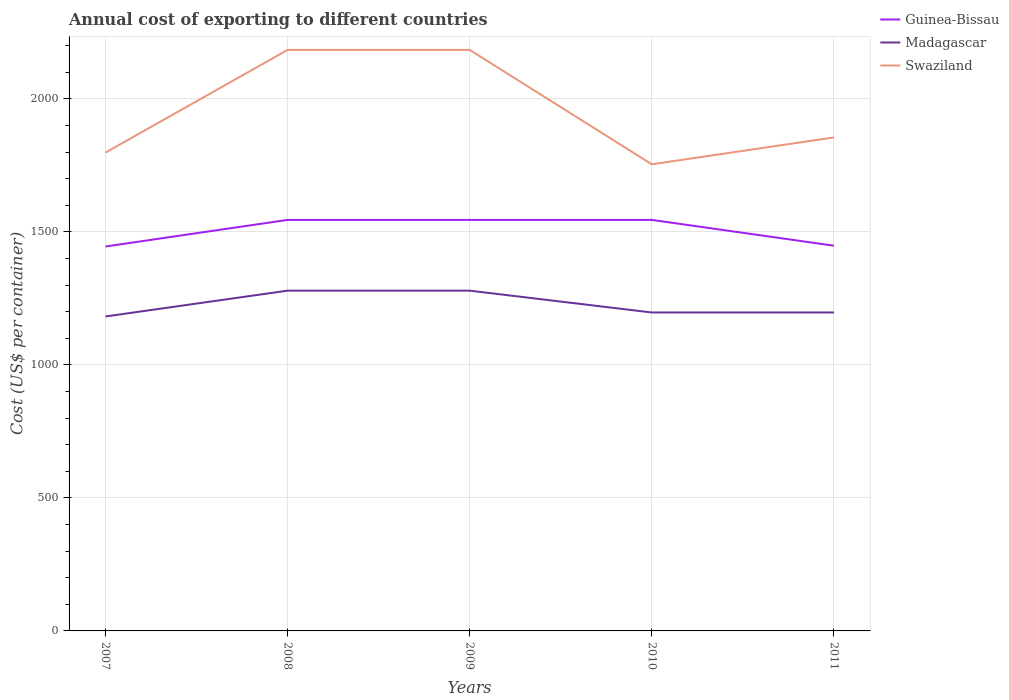Is the number of lines equal to the number of legend labels?
Offer a terse response. Yes. Across all years, what is the maximum total annual cost of exporting in Madagascar?
Ensure brevity in your answer.  1182. In which year was the total annual cost of exporting in Madagascar maximum?
Your answer should be compact. 2007. What is the total total annual cost of exporting in Guinea-Bissau in the graph?
Keep it short and to the point. -100. What is the difference between the highest and the second highest total annual cost of exporting in Swaziland?
Offer a terse response. 430. What is the difference between the highest and the lowest total annual cost of exporting in Swaziland?
Keep it short and to the point. 2. Is the total annual cost of exporting in Swaziland strictly greater than the total annual cost of exporting in Guinea-Bissau over the years?
Keep it short and to the point. No. How many years are there in the graph?
Provide a short and direct response. 5. Are the values on the major ticks of Y-axis written in scientific E-notation?
Your answer should be compact. No. Does the graph contain any zero values?
Offer a terse response. No. Does the graph contain grids?
Offer a very short reply. Yes. What is the title of the graph?
Your response must be concise. Annual cost of exporting to different countries. Does "Cameroon" appear as one of the legend labels in the graph?
Ensure brevity in your answer.  No. What is the label or title of the Y-axis?
Give a very brief answer. Cost (US$ per container). What is the Cost (US$ per container) in Guinea-Bissau in 2007?
Provide a short and direct response. 1445. What is the Cost (US$ per container) in Madagascar in 2007?
Provide a succinct answer. 1182. What is the Cost (US$ per container) in Swaziland in 2007?
Your response must be concise. 1798. What is the Cost (US$ per container) in Guinea-Bissau in 2008?
Provide a short and direct response. 1545. What is the Cost (US$ per container) in Madagascar in 2008?
Your response must be concise. 1279. What is the Cost (US$ per container) of Swaziland in 2008?
Offer a very short reply. 2184. What is the Cost (US$ per container) of Guinea-Bissau in 2009?
Your response must be concise. 1545. What is the Cost (US$ per container) in Madagascar in 2009?
Offer a terse response. 1279. What is the Cost (US$ per container) of Swaziland in 2009?
Make the answer very short. 2184. What is the Cost (US$ per container) of Guinea-Bissau in 2010?
Offer a very short reply. 1545. What is the Cost (US$ per container) in Madagascar in 2010?
Offer a very short reply. 1197. What is the Cost (US$ per container) of Swaziland in 2010?
Offer a terse response. 1754. What is the Cost (US$ per container) of Guinea-Bissau in 2011?
Give a very brief answer. 1448. What is the Cost (US$ per container) of Madagascar in 2011?
Your answer should be compact. 1197. What is the Cost (US$ per container) of Swaziland in 2011?
Give a very brief answer. 1855. Across all years, what is the maximum Cost (US$ per container) of Guinea-Bissau?
Your answer should be very brief. 1545. Across all years, what is the maximum Cost (US$ per container) of Madagascar?
Provide a succinct answer. 1279. Across all years, what is the maximum Cost (US$ per container) of Swaziland?
Give a very brief answer. 2184. Across all years, what is the minimum Cost (US$ per container) in Guinea-Bissau?
Offer a terse response. 1445. Across all years, what is the minimum Cost (US$ per container) of Madagascar?
Provide a succinct answer. 1182. Across all years, what is the minimum Cost (US$ per container) in Swaziland?
Your answer should be very brief. 1754. What is the total Cost (US$ per container) of Guinea-Bissau in the graph?
Your response must be concise. 7528. What is the total Cost (US$ per container) of Madagascar in the graph?
Ensure brevity in your answer.  6134. What is the total Cost (US$ per container) in Swaziland in the graph?
Offer a very short reply. 9775. What is the difference between the Cost (US$ per container) in Guinea-Bissau in 2007 and that in 2008?
Keep it short and to the point. -100. What is the difference between the Cost (US$ per container) of Madagascar in 2007 and that in 2008?
Your response must be concise. -97. What is the difference between the Cost (US$ per container) in Swaziland in 2007 and that in 2008?
Ensure brevity in your answer.  -386. What is the difference between the Cost (US$ per container) of Guinea-Bissau in 2007 and that in 2009?
Offer a very short reply. -100. What is the difference between the Cost (US$ per container) of Madagascar in 2007 and that in 2009?
Your answer should be very brief. -97. What is the difference between the Cost (US$ per container) of Swaziland in 2007 and that in 2009?
Make the answer very short. -386. What is the difference between the Cost (US$ per container) of Guinea-Bissau in 2007 and that in 2010?
Your answer should be compact. -100. What is the difference between the Cost (US$ per container) in Madagascar in 2007 and that in 2010?
Provide a succinct answer. -15. What is the difference between the Cost (US$ per container) in Swaziland in 2007 and that in 2010?
Offer a very short reply. 44. What is the difference between the Cost (US$ per container) in Guinea-Bissau in 2007 and that in 2011?
Make the answer very short. -3. What is the difference between the Cost (US$ per container) in Swaziland in 2007 and that in 2011?
Offer a terse response. -57. What is the difference between the Cost (US$ per container) in Guinea-Bissau in 2008 and that in 2009?
Provide a short and direct response. 0. What is the difference between the Cost (US$ per container) of Madagascar in 2008 and that in 2009?
Offer a terse response. 0. What is the difference between the Cost (US$ per container) in Swaziland in 2008 and that in 2009?
Your answer should be compact. 0. What is the difference between the Cost (US$ per container) in Guinea-Bissau in 2008 and that in 2010?
Your answer should be very brief. 0. What is the difference between the Cost (US$ per container) in Madagascar in 2008 and that in 2010?
Your response must be concise. 82. What is the difference between the Cost (US$ per container) in Swaziland in 2008 and that in 2010?
Provide a short and direct response. 430. What is the difference between the Cost (US$ per container) in Guinea-Bissau in 2008 and that in 2011?
Keep it short and to the point. 97. What is the difference between the Cost (US$ per container) of Madagascar in 2008 and that in 2011?
Provide a succinct answer. 82. What is the difference between the Cost (US$ per container) in Swaziland in 2008 and that in 2011?
Your answer should be compact. 329. What is the difference between the Cost (US$ per container) in Swaziland in 2009 and that in 2010?
Provide a succinct answer. 430. What is the difference between the Cost (US$ per container) in Guinea-Bissau in 2009 and that in 2011?
Make the answer very short. 97. What is the difference between the Cost (US$ per container) of Madagascar in 2009 and that in 2011?
Offer a very short reply. 82. What is the difference between the Cost (US$ per container) in Swaziland in 2009 and that in 2011?
Provide a succinct answer. 329. What is the difference between the Cost (US$ per container) of Guinea-Bissau in 2010 and that in 2011?
Provide a short and direct response. 97. What is the difference between the Cost (US$ per container) in Madagascar in 2010 and that in 2011?
Make the answer very short. 0. What is the difference between the Cost (US$ per container) of Swaziland in 2010 and that in 2011?
Keep it short and to the point. -101. What is the difference between the Cost (US$ per container) of Guinea-Bissau in 2007 and the Cost (US$ per container) of Madagascar in 2008?
Keep it short and to the point. 166. What is the difference between the Cost (US$ per container) of Guinea-Bissau in 2007 and the Cost (US$ per container) of Swaziland in 2008?
Provide a succinct answer. -739. What is the difference between the Cost (US$ per container) of Madagascar in 2007 and the Cost (US$ per container) of Swaziland in 2008?
Provide a succinct answer. -1002. What is the difference between the Cost (US$ per container) in Guinea-Bissau in 2007 and the Cost (US$ per container) in Madagascar in 2009?
Your answer should be very brief. 166. What is the difference between the Cost (US$ per container) in Guinea-Bissau in 2007 and the Cost (US$ per container) in Swaziland in 2009?
Ensure brevity in your answer.  -739. What is the difference between the Cost (US$ per container) of Madagascar in 2007 and the Cost (US$ per container) of Swaziland in 2009?
Provide a short and direct response. -1002. What is the difference between the Cost (US$ per container) of Guinea-Bissau in 2007 and the Cost (US$ per container) of Madagascar in 2010?
Your answer should be very brief. 248. What is the difference between the Cost (US$ per container) of Guinea-Bissau in 2007 and the Cost (US$ per container) of Swaziland in 2010?
Your answer should be very brief. -309. What is the difference between the Cost (US$ per container) of Madagascar in 2007 and the Cost (US$ per container) of Swaziland in 2010?
Ensure brevity in your answer.  -572. What is the difference between the Cost (US$ per container) in Guinea-Bissau in 2007 and the Cost (US$ per container) in Madagascar in 2011?
Give a very brief answer. 248. What is the difference between the Cost (US$ per container) of Guinea-Bissau in 2007 and the Cost (US$ per container) of Swaziland in 2011?
Make the answer very short. -410. What is the difference between the Cost (US$ per container) of Madagascar in 2007 and the Cost (US$ per container) of Swaziland in 2011?
Offer a terse response. -673. What is the difference between the Cost (US$ per container) in Guinea-Bissau in 2008 and the Cost (US$ per container) in Madagascar in 2009?
Your answer should be very brief. 266. What is the difference between the Cost (US$ per container) in Guinea-Bissau in 2008 and the Cost (US$ per container) in Swaziland in 2009?
Offer a very short reply. -639. What is the difference between the Cost (US$ per container) in Madagascar in 2008 and the Cost (US$ per container) in Swaziland in 2009?
Your answer should be very brief. -905. What is the difference between the Cost (US$ per container) in Guinea-Bissau in 2008 and the Cost (US$ per container) in Madagascar in 2010?
Ensure brevity in your answer.  348. What is the difference between the Cost (US$ per container) in Guinea-Bissau in 2008 and the Cost (US$ per container) in Swaziland in 2010?
Offer a terse response. -209. What is the difference between the Cost (US$ per container) in Madagascar in 2008 and the Cost (US$ per container) in Swaziland in 2010?
Your answer should be very brief. -475. What is the difference between the Cost (US$ per container) in Guinea-Bissau in 2008 and the Cost (US$ per container) in Madagascar in 2011?
Keep it short and to the point. 348. What is the difference between the Cost (US$ per container) in Guinea-Bissau in 2008 and the Cost (US$ per container) in Swaziland in 2011?
Your answer should be compact. -310. What is the difference between the Cost (US$ per container) in Madagascar in 2008 and the Cost (US$ per container) in Swaziland in 2011?
Ensure brevity in your answer.  -576. What is the difference between the Cost (US$ per container) of Guinea-Bissau in 2009 and the Cost (US$ per container) of Madagascar in 2010?
Your answer should be compact. 348. What is the difference between the Cost (US$ per container) of Guinea-Bissau in 2009 and the Cost (US$ per container) of Swaziland in 2010?
Give a very brief answer. -209. What is the difference between the Cost (US$ per container) in Madagascar in 2009 and the Cost (US$ per container) in Swaziland in 2010?
Ensure brevity in your answer.  -475. What is the difference between the Cost (US$ per container) of Guinea-Bissau in 2009 and the Cost (US$ per container) of Madagascar in 2011?
Provide a succinct answer. 348. What is the difference between the Cost (US$ per container) of Guinea-Bissau in 2009 and the Cost (US$ per container) of Swaziland in 2011?
Give a very brief answer. -310. What is the difference between the Cost (US$ per container) of Madagascar in 2009 and the Cost (US$ per container) of Swaziland in 2011?
Provide a succinct answer. -576. What is the difference between the Cost (US$ per container) of Guinea-Bissau in 2010 and the Cost (US$ per container) of Madagascar in 2011?
Your answer should be very brief. 348. What is the difference between the Cost (US$ per container) in Guinea-Bissau in 2010 and the Cost (US$ per container) in Swaziland in 2011?
Ensure brevity in your answer.  -310. What is the difference between the Cost (US$ per container) of Madagascar in 2010 and the Cost (US$ per container) of Swaziland in 2011?
Your answer should be compact. -658. What is the average Cost (US$ per container) of Guinea-Bissau per year?
Ensure brevity in your answer.  1505.6. What is the average Cost (US$ per container) of Madagascar per year?
Ensure brevity in your answer.  1226.8. What is the average Cost (US$ per container) in Swaziland per year?
Offer a very short reply. 1955. In the year 2007, what is the difference between the Cost (US$ per container) of Guinea-Bissau and Cost (US$ per container) of Madagascar?
Keep it short and to the point. 263. In the year 2007, what is the difference between the Cost (US$ per container) of Guinea-Bissau and Cost (US$ per container) of Swaziland?
Provide a succinct answer. -353. In the year 2007, what is the difference between the Cost (US$ per container) in Madagascar and Cost (US$ per container) in Swaziland?
Your answer should be compact. -616. In the year 2008, what is the difference between the Cost (US$ per container) of Guinea-Bissau and Cost (US$ per container) of Madagascar?
Provide a succinct answer. 266. In the year 2008, what is the difference between the Cost (US$ per container) of Guinea-Bissau and Cost (US$ per container) of Swaziland?
Ensure brevity in your answer.  -639. In the year 2008, what is the difference between the Cost (US$ per container) in Madagascar and Cost (US$ per container) in Swaziland?
Your answer should be very brief. -905. In the year 2009, what is the difference between the Cost (US$ per container) of Guinea-Bissau and Cost (US$ per container) of Madagascar?
Ensure brevity in your answer.  266. In the year 2009, what is the difference between the Cost (US$ per container) in Guinea-Bissau and Cost (US$ per container) in Swaziland?
Give a very brief answer. -639. In the year 2009, what is the difference between the Cost (US$ per container) in Madagascar and Cost (US$ per container) in Swaziland?
Keep it short and to the point. -905. In the year 2010, what is the difference between the Cost (US$ per container) in Guinea-Bissau and Cost (US$ per container) in Madagascar?
Keep it short and to the point. 348. In the year 2010, what is the difference between the Cost (US$ per container) of Guinea-Bissau and Cost (US$ per container) of Swaziland?
Keep it short and to the point. -209. In the year 2010, what is the difference between the Cost (US$ per container) in Madagascar and Cost (US$ per container) in Swaziland?
Your response must be concise. -557. In the year 2011, what is the difference between the Cost (US$ per container) in Guinea-Bissau and Cost (US$ per container) in Madagascar?
Offer a terse response. 251. In the year 2011, what is the difference between the Cost (US$ per container) in Guinea-Bissau and Cost (US$ per container) in Swaziland?
Your response must be concise. -407. In the year 2011, what is the difference between the Cost (US$ per container) in Madagascar and Cost (US$ per container) in Swaziland?
Give a very brief answer. -658. What is the ratio of the Cost (US$ per container) in Guinea-Bissau in 2007 to that in 2008?
Ensure brevity in your answer.  0.94. What is the ratio of the Cost (US$ per container) in Madagascar in 2007 to that in 2008?
Your answer should be very brief. 0.92. What is the ratio of the Cost (US$ per container) of Swaziland in 2007 to that in 2008?
Keep it short and to the point. 0.82. What is the ratio of the Cost (US$ per container) in Guinea-Bissau in 2007 to that in 2009?
Keep it short and to the point. 0.94. What is the ratio of the Cost (US$ per container) of Madagascar in 2007 to that in 2009?
Your response must be concise. 0.92. What is the ratio of the Cost (US$ per container) of Swaziland in 2007 to that in 2009?
Keep it short and to the point. 0.82. What is the ratio of the Cost (US$ per container) in Guinea-Bissau in 2007 to that in 2010?
Ensure brevity in your answer.  0.94. What is the ratio of the Cost (US$ per container) of Madagascar in 2007 to that in 2010?
Your answer should be compact. 0.99. What is the ratio of the Cost (US$ per container) of Swaziland in 2007 to that in 2010?
Provide a succinct answer. 1.03. What is the ratio of the Cost (US$ per container) of Guinea-Bissau in 2007 to that in 2011?
Keep it short and to the point. 1. What is the ratio of the Cost (US$ per container) of Madagascar in 2007 to that in 2011?
Your answer should be very brief. 0.99. What is the ratio of the Cost (US$ per container) of Swaziland in 2007 to that in 2011?
Your answer should be compact. 0.97. What is the ratio of the Cost (US$ per container) in Swaziland in 2008 to that in 2009?
Your answer should be very brief. 1. What is the ratio of the Cost (US$ per container) in Madagascar in 2008 to that in 2010?
Your answer should be compact. 1.07. What is the ratio of the Cost (US$ per container) in Swaziland in 2008 to that in 2010?
Provide a short and direct response. 1.25. What is the ratio of the Cost (US$ per container) of Guinea-Bissau in 2008 to that in 2011?
Keep it short and to the point. 1.07. What is the ratio of the Cost (US$ per container) of Madagascar in 2008 to that in 2011?
Provide a succinct answer. 1.07. What is the ratio of the Cost (US$ per container) of Swaziland in 2008 to that in 2011?
Your answer should be compact. 1.18. What is the ratio of the Cost (US$ per container) in Madagascar in 2009 to that in 2010?
Provide a short and direct response. 1.07. What is the ratio of the Cost (US$ per container) of Swaziland in 2009 to that in 2010?
Offer a terse response. 1.25. What is the ratio of the Cost (US$ per container) of Guinea-Bissau in 2009 to that in 2011?
Your answer should be very brief. 1.07. What is the ratio of the Cost (US$ per container) in Madagascar in 2009 to that in 2011?
Ensure brevity in your answer.  1.07. What is the ratio of the Cost (US$ per container) of Swaziland in 2009 to that in 2011?
Give a very brief answer. 1.18. What is the ratio of the Cost (US$ per container) of Guinea-Bissau in 2010 to that in 2011?
Give a very brief answer. 1.07. What is the ratio of the Cost (US$ per container) in Swaziland in 2010 to that in 2011?
Your response must be concise. 0.95. What is the difference between the highest and the second highest Cost (US$ per container) in Guinea-Bissau?
Offer a very short reply. 0. What is the difference between the highest and the second highest Cost (US$ per container) in Swaziland?
Offer a terse response. 0. What is the difference between the highest and the lowest Cost (US$ per container) in Madagascar?
Offer a very short reply. 97. What is the difference between the highest and the lowest Cost (US$ per container) of Swaziland?
Make the answer very short. 430. 